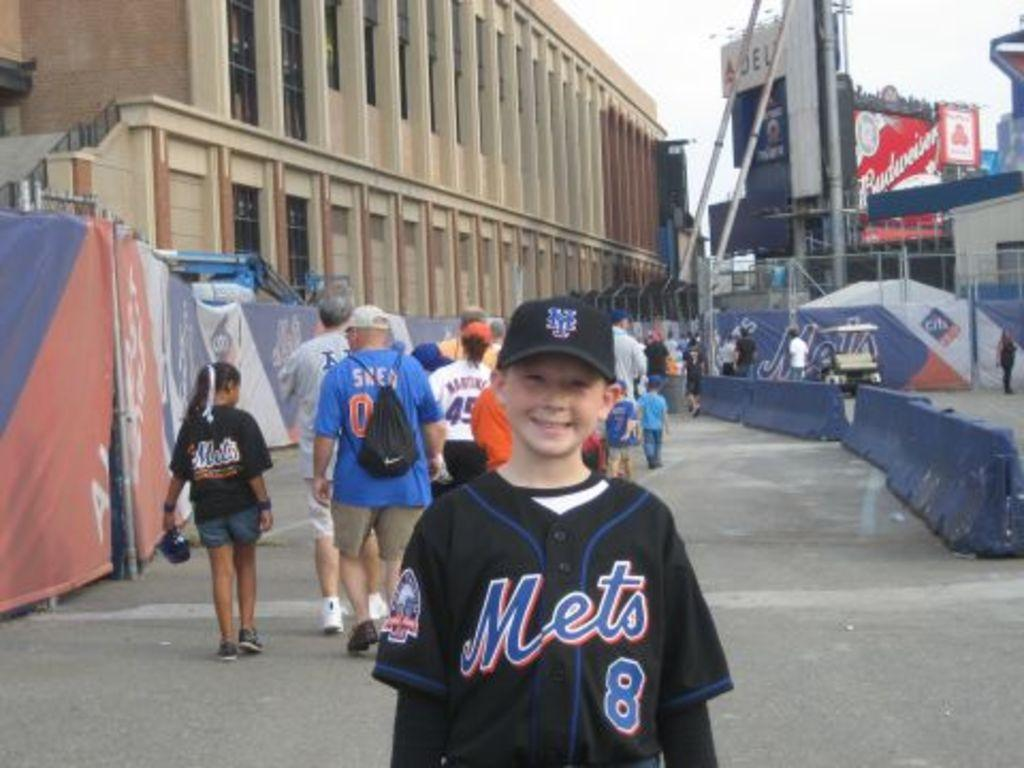<image>
Summarize the visual content of the image. A young boy wearing a black Mets 8 jersey. 